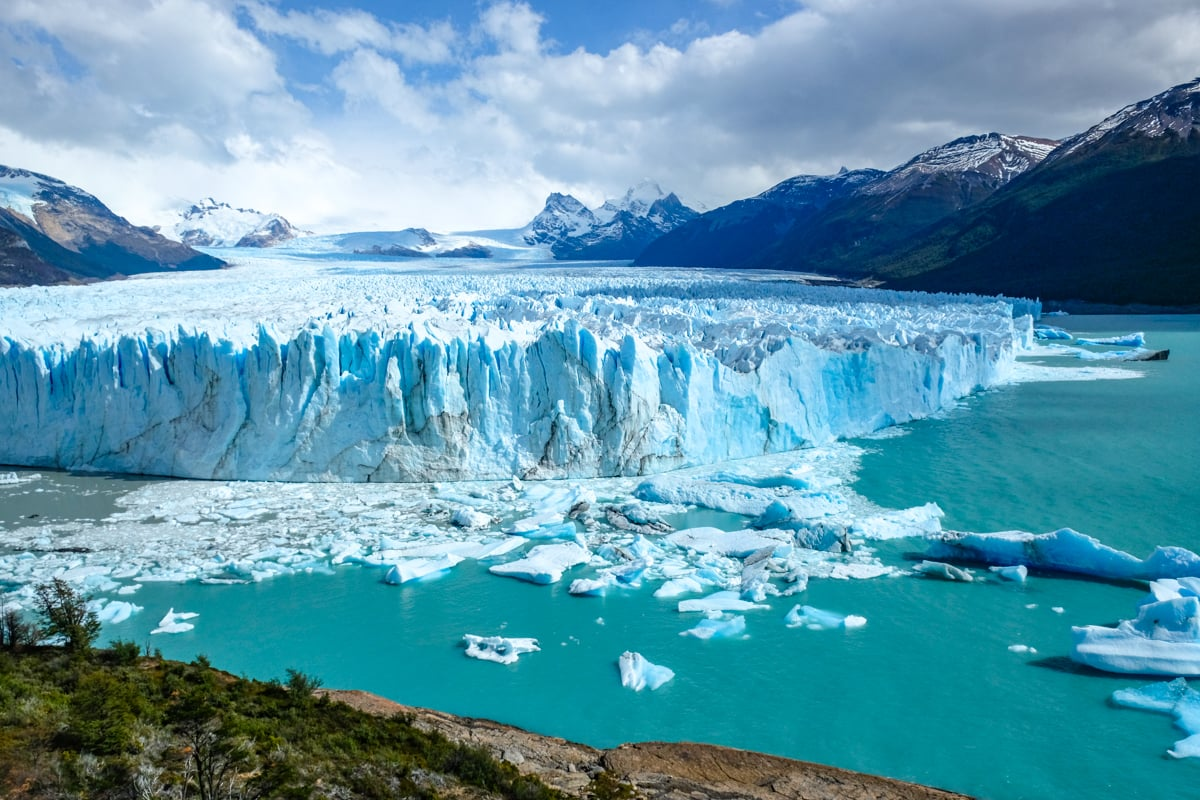What are some of the threats to glaciers like Perito Moreno? Glaciers worldwide, including Perito Moreno, face several threats, primarily from climate change. Rising global temperatures lead to increased glacial melt and reduced snowfall, which, over time, can result in a decrease in glacier size and freshwater supply. Pollution and human development can also impact glaciers by contributing to global warming and physically altering the landscape. While Perito Moreno is known for maintaining its mass due to its unique cyclical advance and retreat pattern, it is not immune to the broader consequences of climate change. 